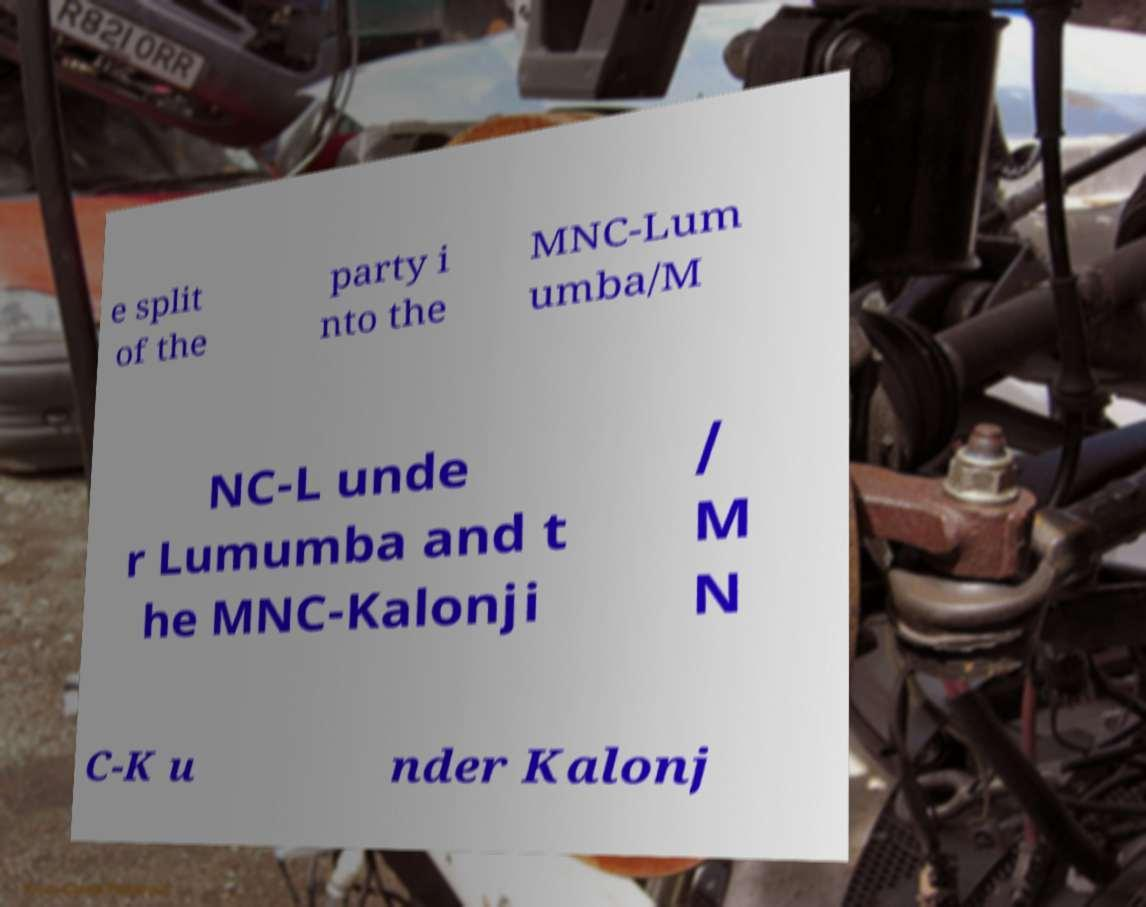Could you assist in decoding the text presented in this image and type it out clearly? e split of the party i nto the MNC-Lum umba/M NC-L unde r Lumumba and t he MNC-Kalonji / M N C-K u nder Kalonj 